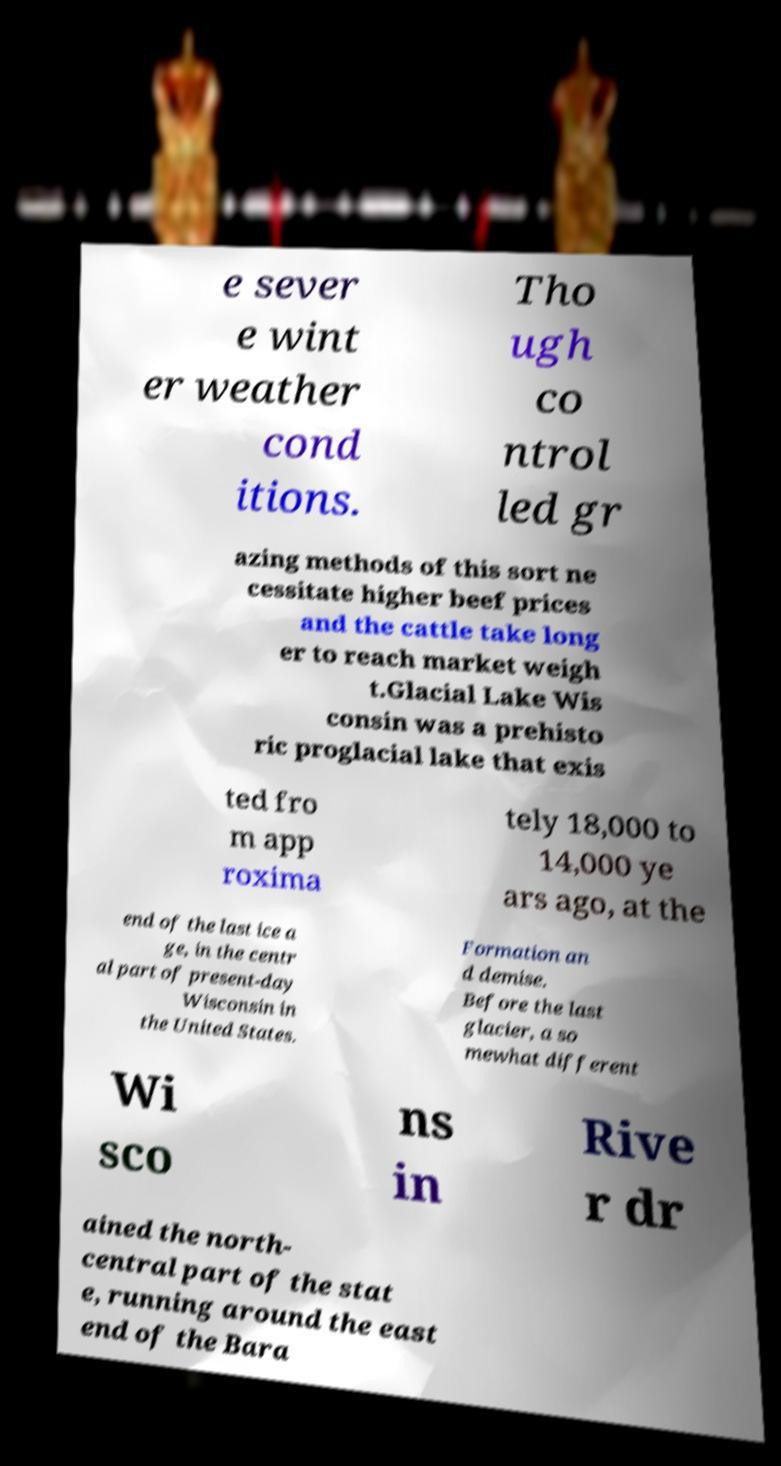Please read and relay the text visible in this image. What does it say? e sever e wint er weather cond itions. Tho ugh co ntrol led gr azing methods of this sort ne cessitate higher beef prices and the cattle take long er to reach market weigh t.Glacial Lake Wis consin was a prehisto ric proglacial lake that exis ted fro m app roxima tely 18,000 to 14,000 ye ars ago, at the end of the last ice a ge, in the centr al part of present-day Wisconsin in the United States. Formation an d demise. Before the last glacier, a so mewhat different Wi sco ns in Rive r dr ained the north- central part of the stat e, running around the east end of the Bara 